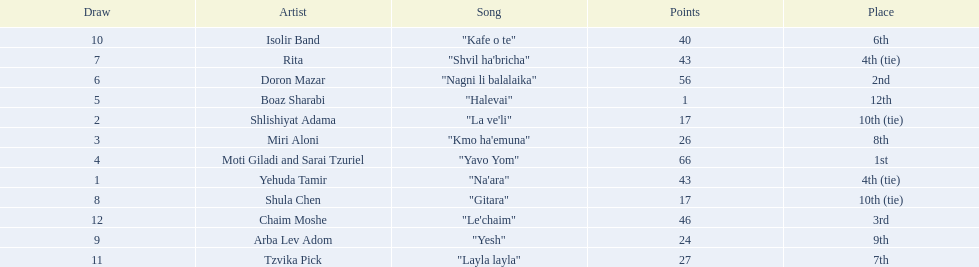What is the place of the contestant who received only 1 point? 12th. What is the name of the artist listed in the previous question? Boaz Sharabi. 